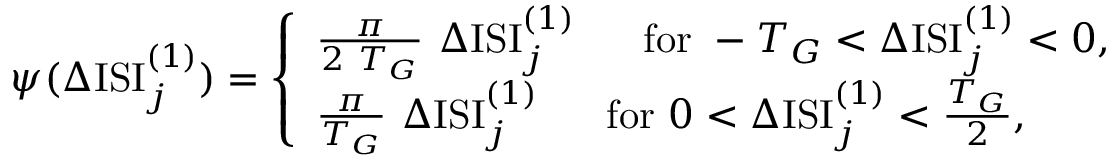Convert formula to latex. <formula><loc_0><loc_0><loc_500><loc_500>\psi ( \Delta I S I _ { j } ^ { ( 1 ) } ) = \left \{ \begin{array} { l } { \frac { \pi } { 2 T _ { G } } \Delta I S I _ { j } ^ { ( 1 ) } f o r - { T _ { G } } < \Delta I S I _ { j } ^ { ( 1 ) } < 0 , } \\ { \frac { \pi } { T _ { G } } \Delta I S I _ { j } ^ { ( 1 ) } f o r 0 < \Delta I S I _ { j } ^ { ( 1 ) } < { \frac { T _ { G } } { 2 } } , } \end{array}</formula> 